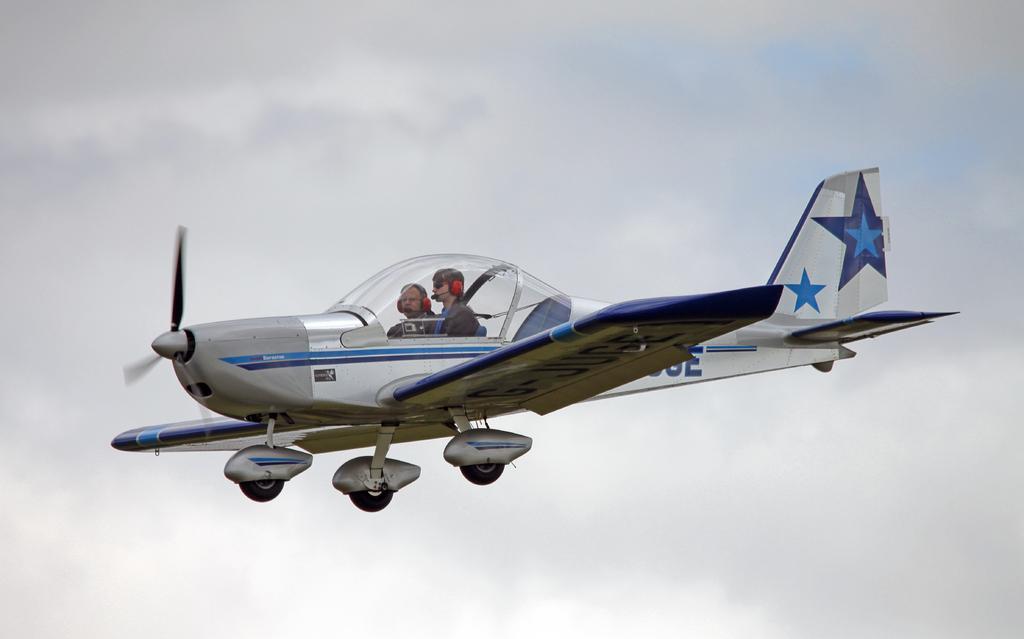Describe this image in one or two sentences. It is an aeroplane, there are 2 persons sitting in it. It is in white and grey color. At the top it is the sky. 